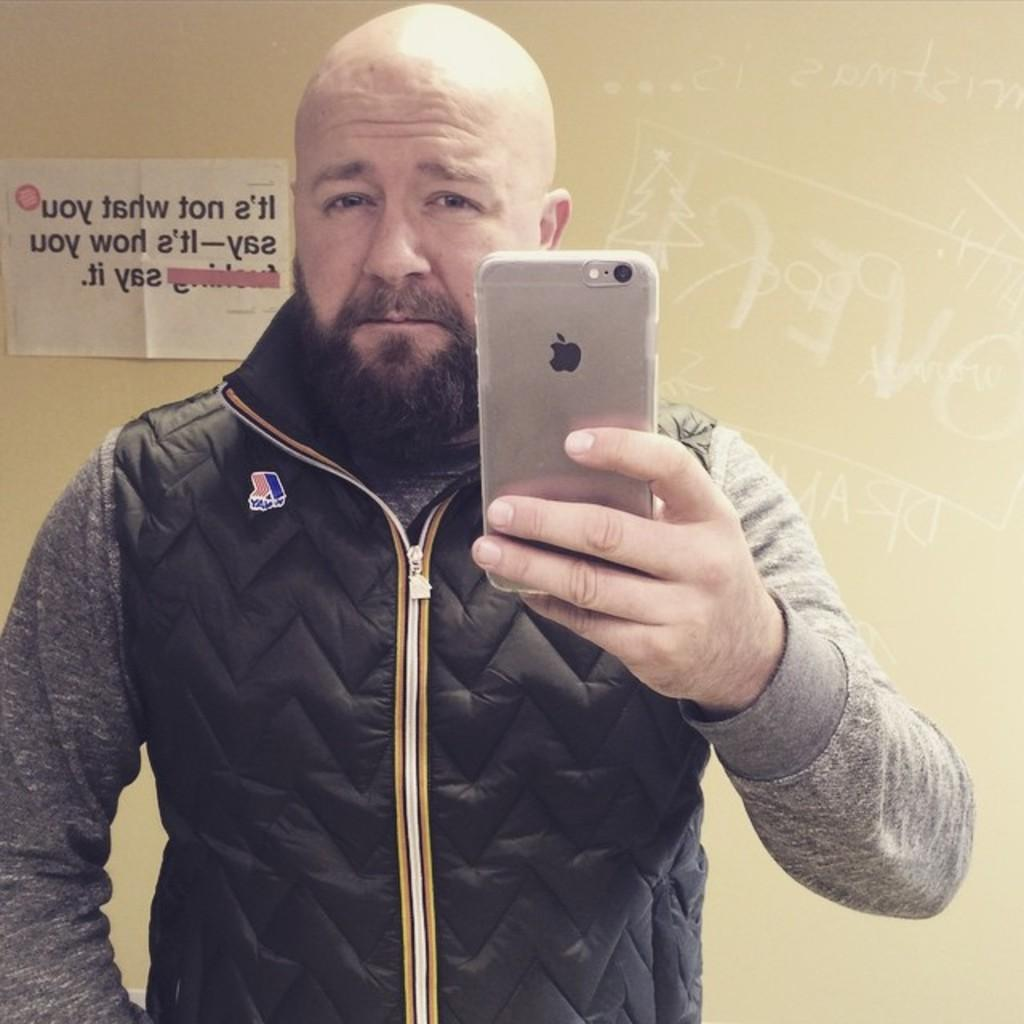What is the person in the image doing? The person is standing. What object is the person holding in the image? The person is holding a phone. What type of clothing is the person wearing? The person is wearing a jacket. What can be seen in the background of the image? There is a wall and a poster in the background of the image. How many sheep are visible in the image? There are no sheep present in the image. What is the person's preferred way of walking in the image? The image does not provide information about the person's preferred way of walking. 